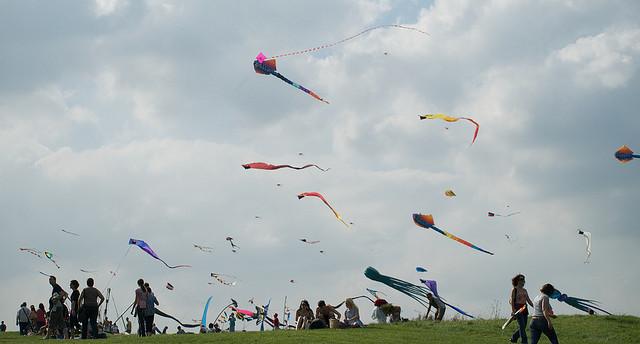What do the people have on their hands?
Be succinct. Kites. How many kites are in this image?
Give a very brief answer. 30. What color is the highest kite?
Quick response, please. Pink. Is it cloudy out?
Answer briefly. Yes. How many kites are in the picture?
Short answer required. 20. What color is the kite to the right?
Short answer required. Orange. Are there near sand?
Give a very brief answer. No. How many people are shown?
Be succinct. 27. Where are the kites?
Answer briefly. In sky. Is it cloudy?
Concise answer only. Yes. How many kites in the sky?
Quick response, please. 30. 